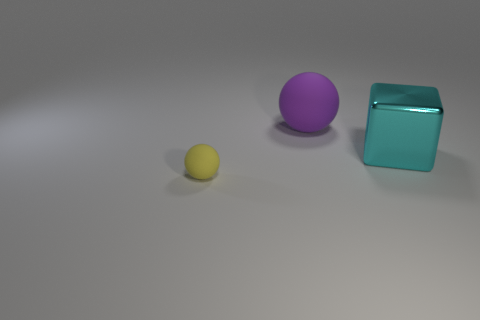Subtract all blocks. How many objects are left? 2 Add 2 tiny matte things. How many objects exist? 5 Add 1 large cyan metallic objects. How many large cyan metallic objects exist? 2 Subtract 0 green blocks. How many objects are left? 3 Subtract all yellow rubber cubes. Subtract all rubber balls. How many objects are left? 1 Add 2 spheres. How many spheres are left? 4 